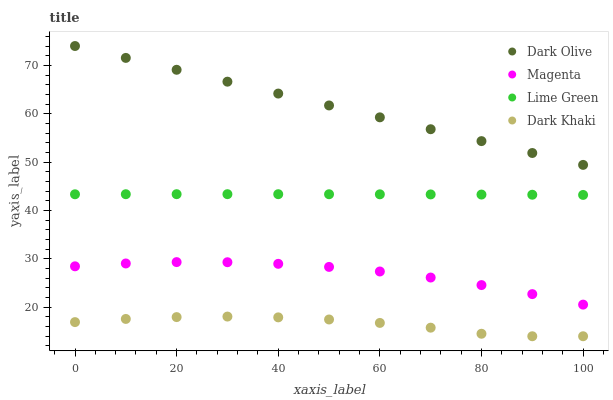Does Dark Khaki have the minimum area under the curve?
Answer yes or no. Yes. Does Dark Olive have the maximum area under the curve?
Answer yes or no. Yes. Does Magenta have the minimum area under the curve?
Answer yes or no. No. Does Magenta have the maximum area under the curve?
Answer yes or no. No. Is Dark Olive the smoothest?
Answer yes or no. Yes. Is Dark Khaki the roughest?
Answer yes or no. Yes. Is Magenta the smoothest?
Answer yes or no. No. Is Magenta the roughest?
Answer yes or no. No. Does Dark Khaki have the lowest value?
Answer yes or no. Yes. Does Magenta have the lowest value?
Answer yes or no. No. Does Dark Olive have the highest value?
Answer yes or no. Yes. Does Magenta have the highest value?
Answer yes or no. No. Is Dark Khaki less than Dark Olive?
Answer yes or no. Yes. Is Dark Olive greater than Lime Green?
Answer yes or no. Yes. Does Dark Khaki intersect Dark Olive?
Answer yes or no. No. 